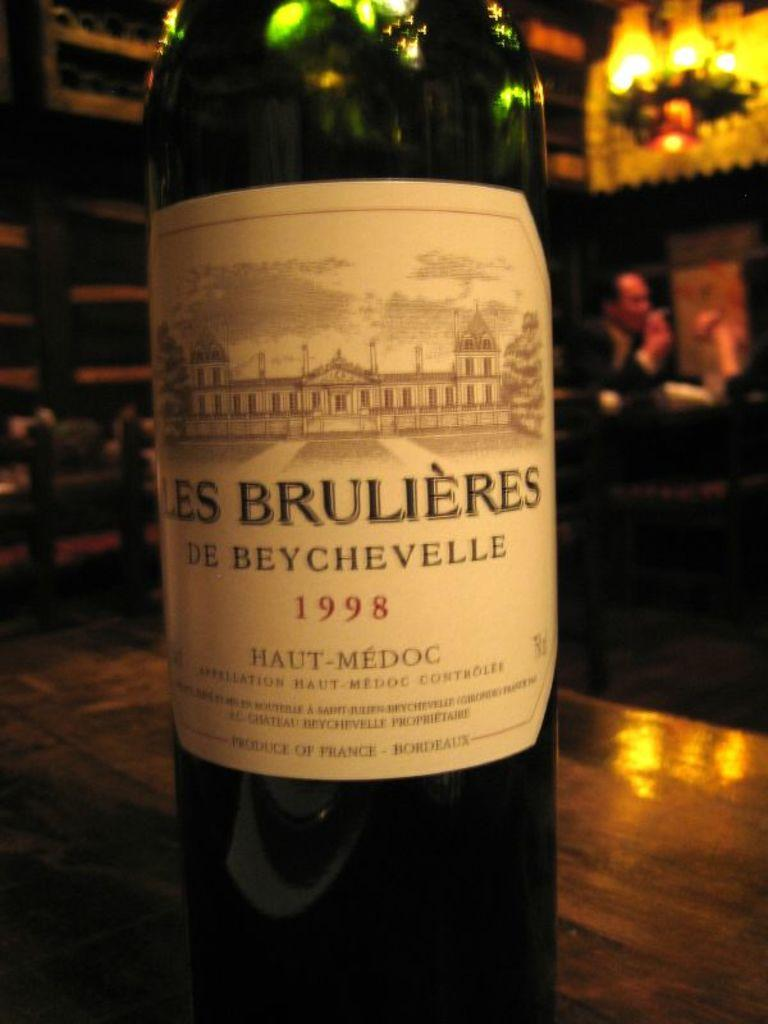<image>
Relay a brief, clear account of the picture shown. A bottle of French wine made in the year 1998. 